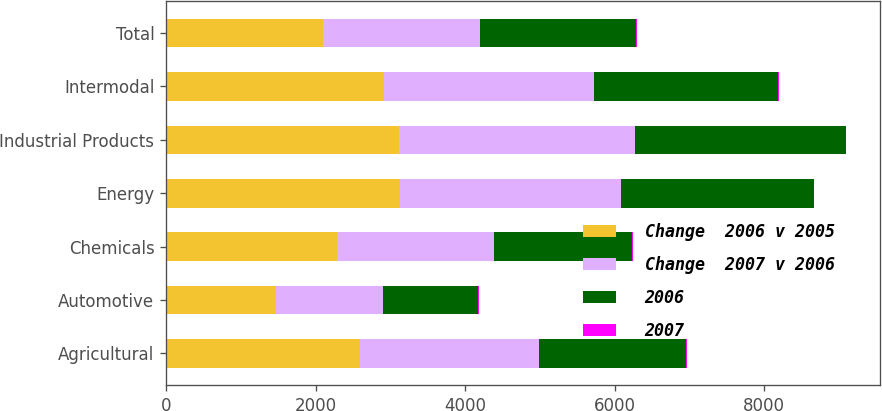<chart> <loc_0><loc_0><loc_500><loc_500><stacked_bar_chart><ecel><fcel>Agricultural<fcel>Automotive<fcel>Chemicals<fcel>Energy<fcel>Industrial Products<fcel>Intermodal<fcel>Total<nl><fcel>Change  2006 v 2005<fcel>2597<fcel>1469<fcel>2293<fcel>3136<fcel>3110<fcel>2911<fcel>2098<nl><fcel>Change  2007 v 2006<fcel>2395<fcel>1438<fcel>2098<fcel>2953<fcel>3168<fcel>2810<fcel>2098<nl><fcel>2006<fcel>1971<fcel>1273<fcel>1848<fcel>2578<fcel>2814<fcel>2473<fcel>2098<nl><fcel>2007<fcel>8<fcel>2<fcel>9<fcel>6<fcel>2<fcel>4<fcel>4<nl></chart> 